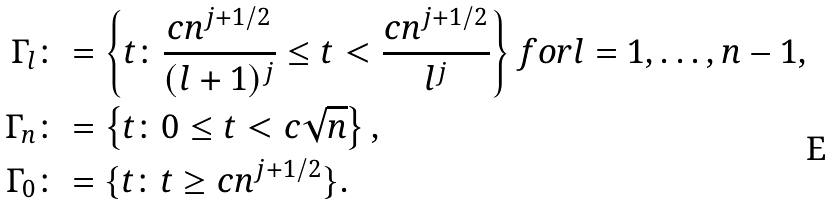Convert formula to latex. <formula><loc_0><loc_0><loc_500><loc_500>\Gamma _ { l } & \colon = \left \{ t \colon \frac { c n ^ { j + 1 / 2 } } { ( l + 1 ) ^ { j } } \leq t < \frac { c n ^ { j + 1 / 2 } } { l ^ { j } } \right \} f o r l = 1 , \dots , n - 1 , \\ \Gamma _ { n } & \colon = \left \{ t \colon 0 \leq t < c \sqrt { n } \right \} , \\ \Gamma _ { 0 } & \colon = \{ t \colon t \geq c n ^ { j + 1 / 2 } \} .</formula> 